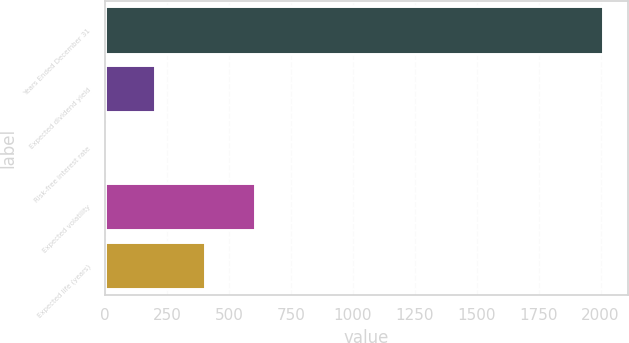<chart> <loc_0><loc_0><loc_500><loc_500><bar_chart><fcel>Years Ended December 31<fcel>Expected dividend yield<fcel>Risk-free interest rate<fcel>Expected volatility<fcel>Expected life (years)<nl><fcel>2010<fcel>203.52<fcel>2.8<fcel>604.96<fcel>404.24<nl></chart> 